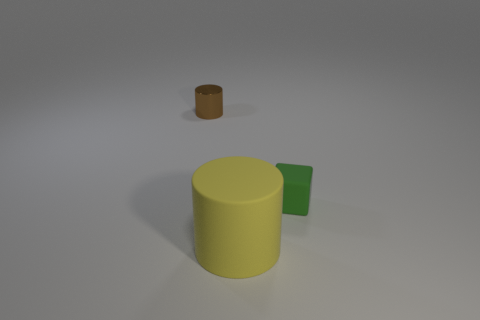What size is the other object that is made of the same material as the yellow thing?
Your answer should be compact. Small. Do the object in front of the tiny green block and the thing behind the tiny green cube have the same size?
Keep it short and to the point. No. What is the material of the brown thing that is the same size as the green rubber block?
Offer a terse response. Metal. What is the material of the thing that is behind the large yellow rubber cylinder and left of the green cube?
Your response must be concise. Metal. Are any tiny red things visible?
Provide a succinct answer. No. Are there any other things that are the same shape as the green rubber object?
Offer a terse response. No. What shape is the small thing right of the cylinder behind the small thing that is to the right of the big cylinder?
Provide a short and direct response. Cube. What shape is the small shiny object?
Your response must be concise. Cylinder. There is a object on the right side of the yellow matte cylinder; what color is it?
Your answer should be compact. Green. Is the size of the matte object that is in front of the green thing the same as the brown shiny thing?
Provide a short and direct response. No. 